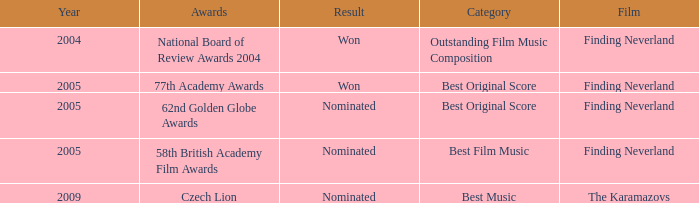How many years were there for the 62nd golden globe awards? 2005.0. 